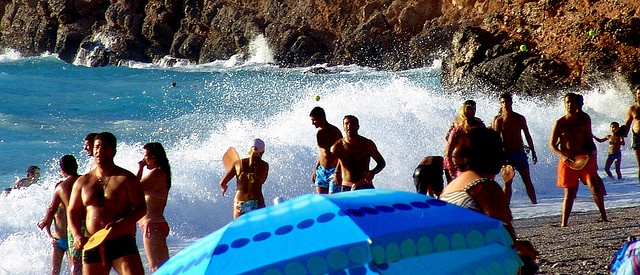Describe the objects in this image and their specific colors. I can see umbrella in black, lightblue, darkblue, and blue tones, people in black, maroon, brown, and khaki tones, people in black, maroon, gray, and tan tones, people in black, maroon, lightgray, and darkgray tones, and people in black, maroon, brown, and tan tones in this image. 